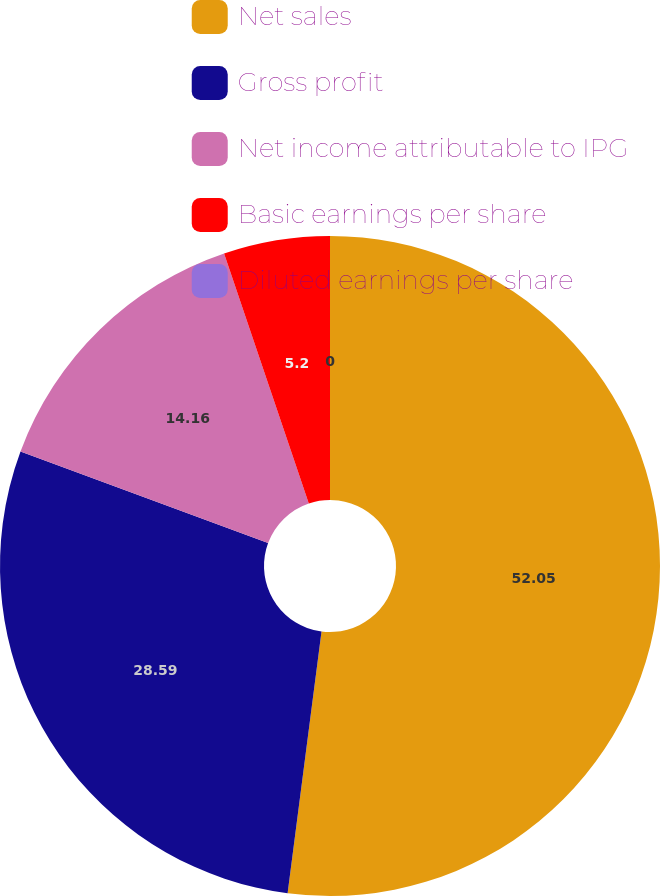Convert chart to OTSL. <chart><loc_0><loc_0><loc_500><loc_500><pie_chart><fcel>Net sales<fcel>Gross profit<fcel>Net income attributable to IPG<fcel>Basic earnings per share<fcel>Diluted earnings per share<nl><fcel>52.05%<fcel>28.59%<fcel>14.16%<fcel>5.2%<fcel>0.0%<nl></chart> 